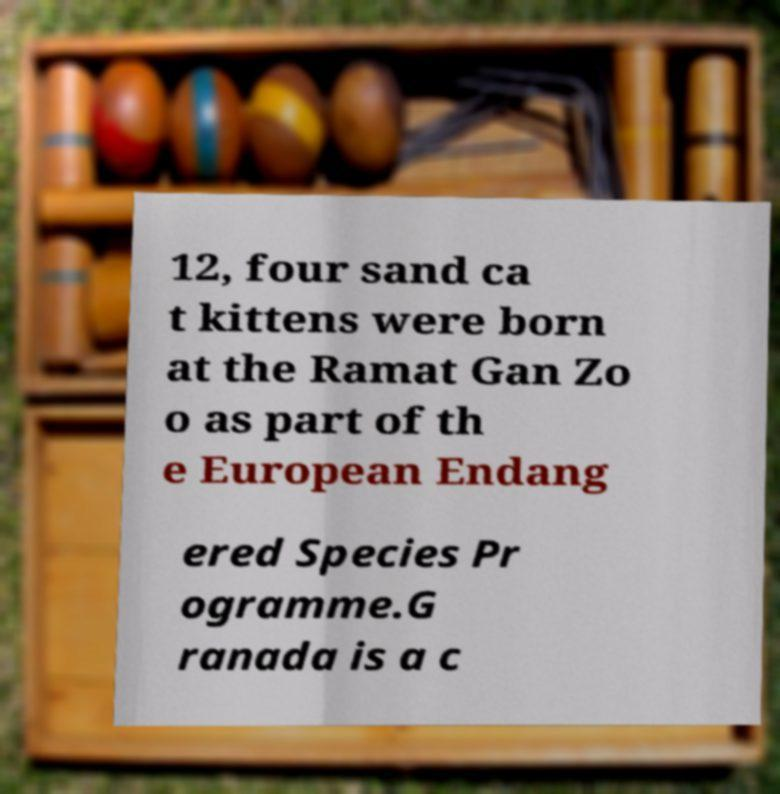Please read and relay the text visible in this image. What does it say? 12, four sand ca t kittens were born at the Ramat Gan Zo o as part of th e European Endang ered Species Pr ogramme.G ranada is a c 